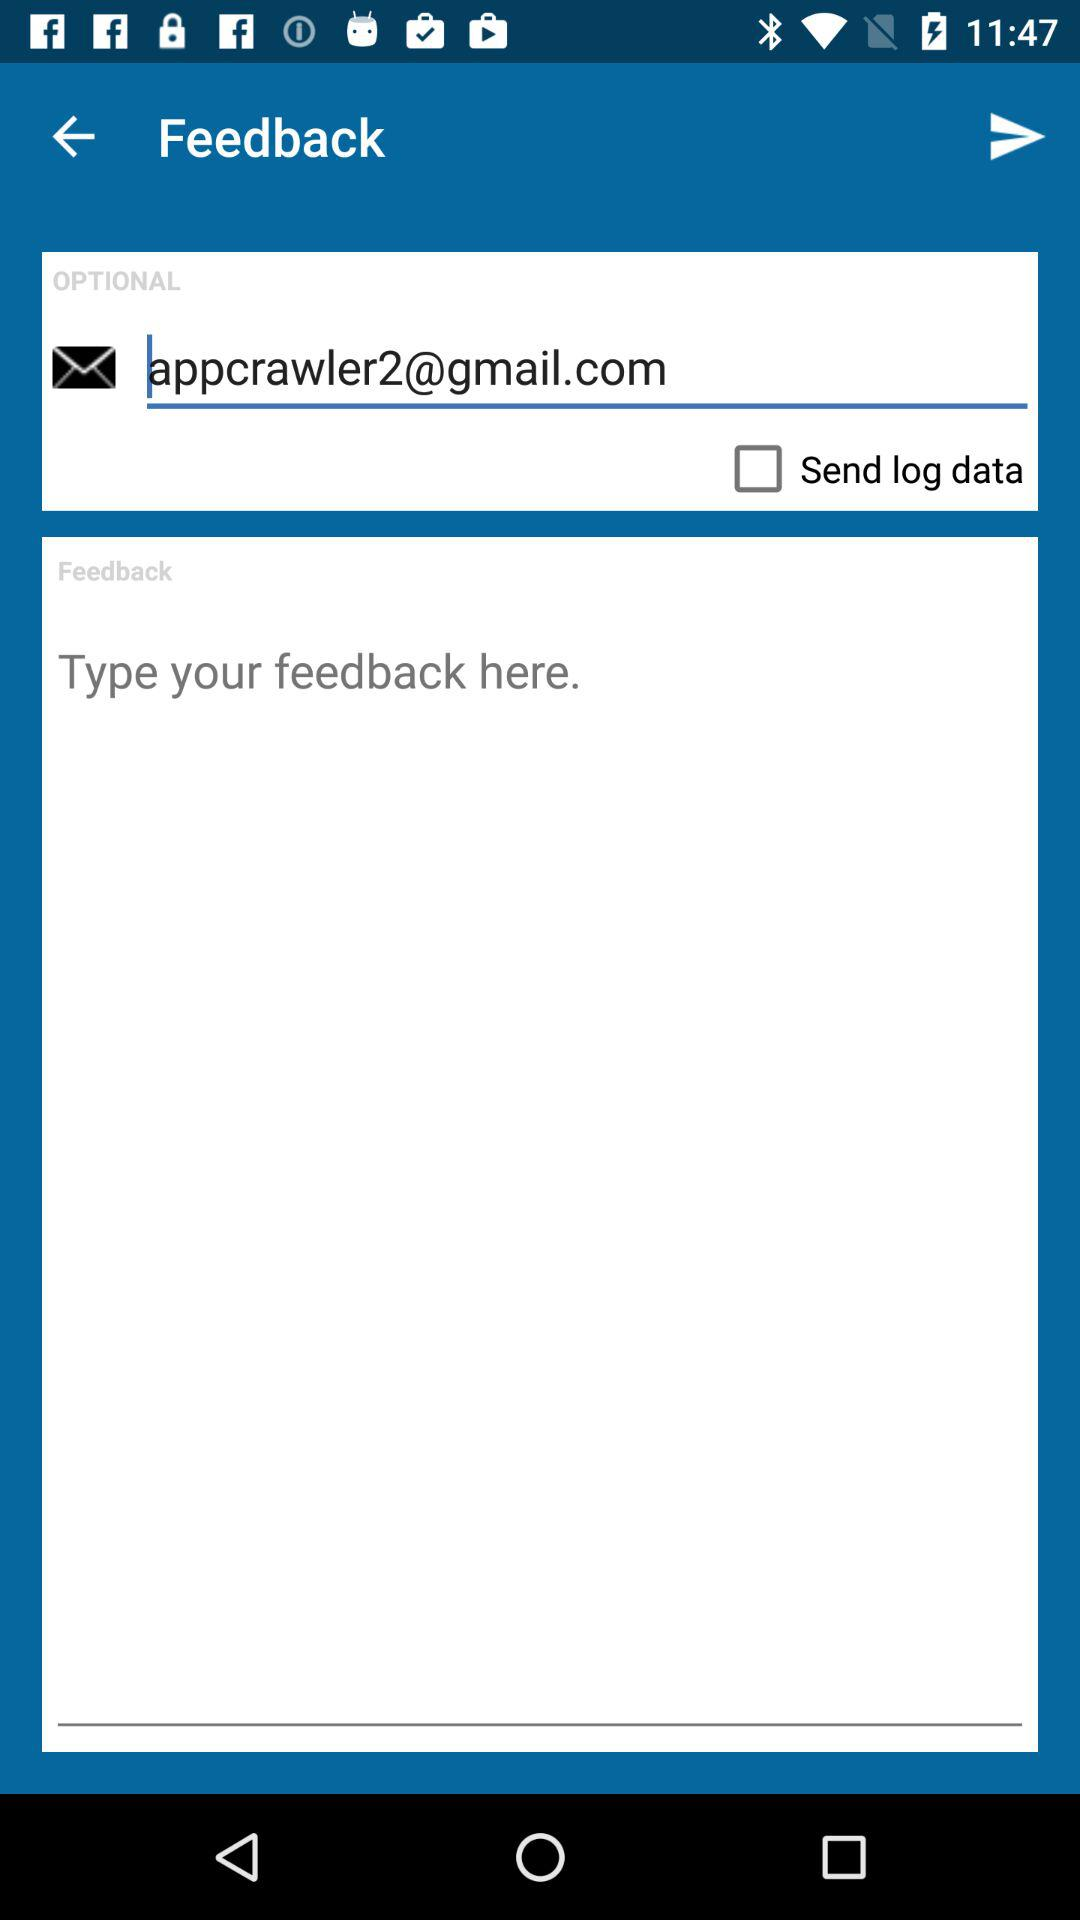What is the email address? The email address is appcrawler2@gmail.com. 